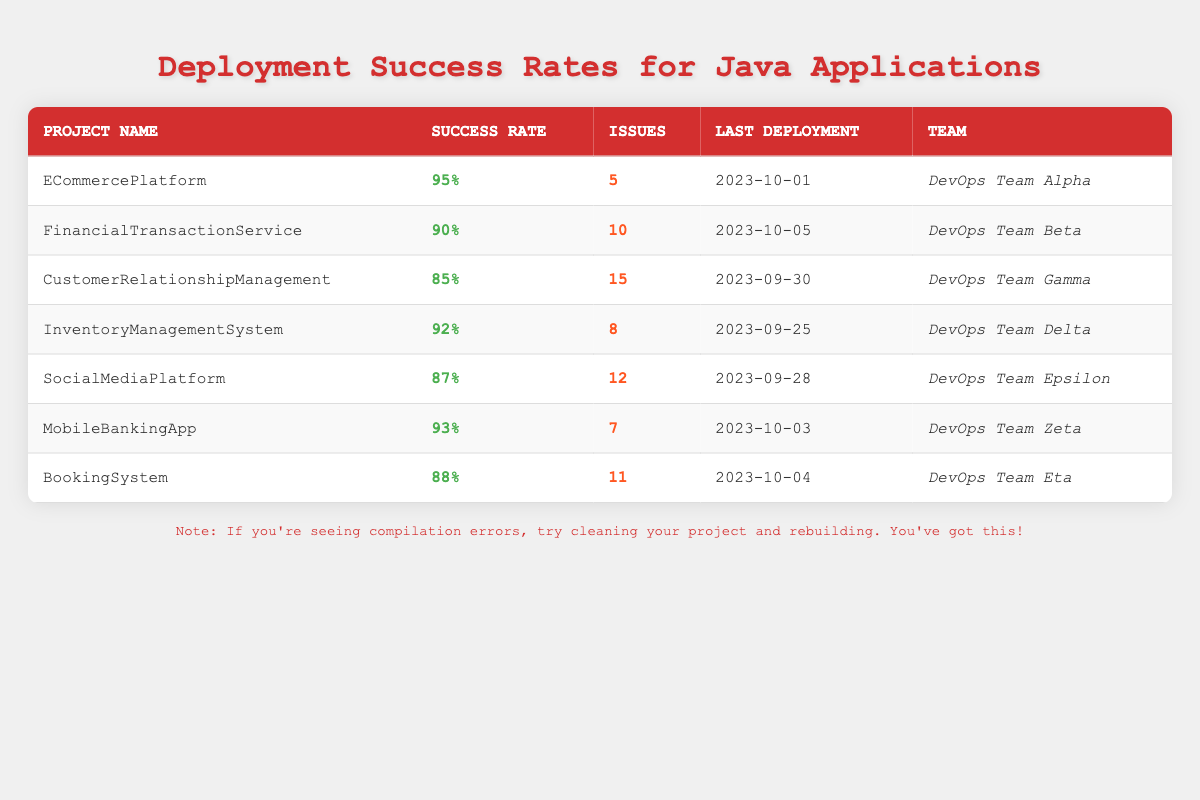What is the success rate of the ECommercePlatform? The success rate for ECommercePlatform is listed in the table under the Success Rate column. It states "95%".
Answer: 95% Which project had the highest number of issues? By comparing the Issues column, CustomerRelationshipManagement has 15 issues, which is the highest compared to the others.
Answer: CustomerRelationshipManagement What is the average success rate for all the projects? To find the average, first convert each success rate to a decimal: 0.95, 0.90, 0.85, 0.92, 0.87, 0.93, 0.88. Summing these gives 6.20, and dividing by 7 (the number of projects) results in approximately 0.8857. Converting this back to a percentage gives a final average success rate of 88.57%.
Answer: 88.57% Did the FinancialTransactionService have more or fewer issues than the InventoryManagementSystem? The FinancialTransactionService has 10 issues while the InventoryManagementSystem has 8 issues. Since 10 is greater than 8, it had more issues.
Answer: More How many projects had a success rate of 90% or higher? By counting the success rates that are 90% or higher (ECommercePlatform, FinancialTransactionService, InventoryManagementSystem, MobileBankingApp), a total of 4 projects meet this condition.
Answer: 4 What is the success rate difference between the highest and lowest rates? The highest success rate is 95% (ECommercePlatform) and the lowest is 85% (CustomerRelationshipManagement). The difference is 95% - 85% = 10%.
Answer: 10% Which project had the last deployment on October 5, 2023? The table shows that FinancialTransactionService had its last deployment on this date, as noted in the Last Deployment column.
Answer: FinancialTransactionService Is the success rate for SocialMediaPlatform below the average success rate? The average success rate is approximately 88.57%. SocialMediaPlatform has a success rate of 87%, which is less than the average.
Answer: Yes Which two teams have the same number of issues as the MobileBankingApp? MobileBankingApp has 7 issues. Checking the Issues column reveals that DevOps Team Alpha (ECommercePlatform) has 5 issues while DevOps Team Delta (InventoryManagementSystem) has 8 issues. No teams match MobileBankingApp’s number of issues.
Answer: None What was the most recent deployment date among all projects? The most recent date from the Last Deployment column is October 5, 2023, corresponding to the FinancialTransactionService.
Answer: October 5, 2023 